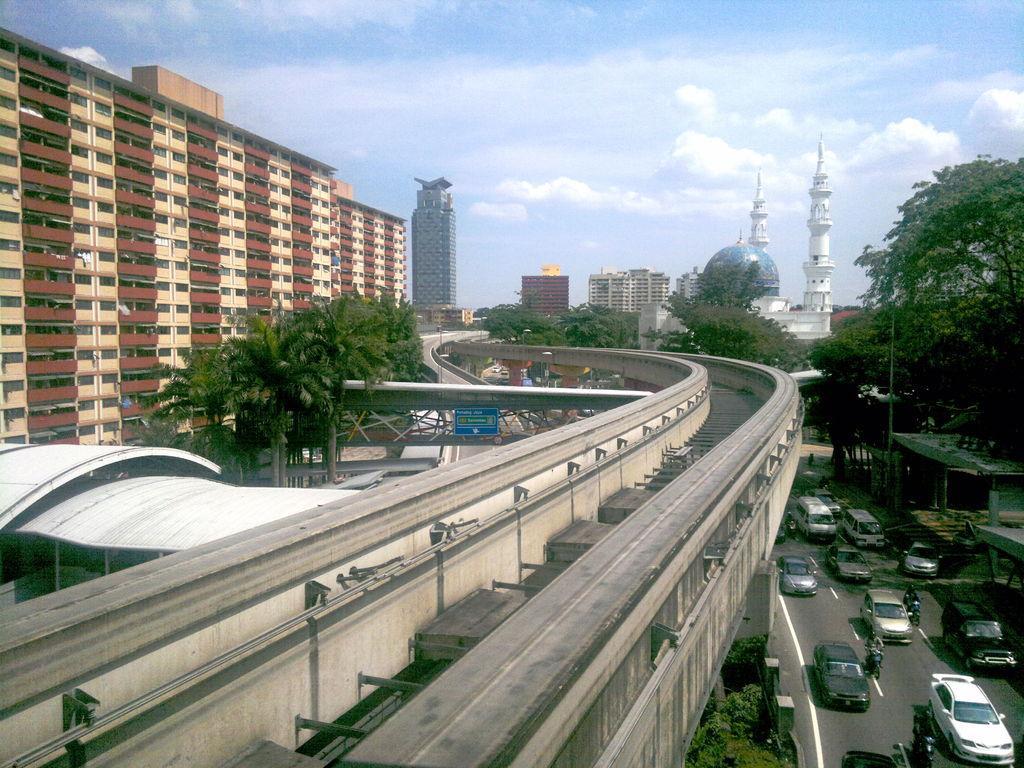Can you describe this image briefly? In the middle of the picture we can see the metro train tracks and beside it, we can see some trees, buildings and opposite side also we can see some trees and the road with vehicles and in the background we can see some trees, building, mosque and the sky with clouds. 